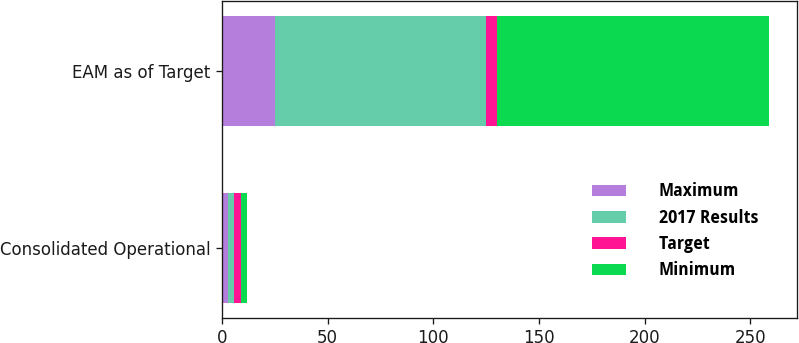Convert chart to OTSL. <chart><loc_0><loc_0><loc_500><loc_500><stacked_bar_chart><ecel><fcel>Consolidated Operational<fcel>EAM as of Target<nl><fcel>Maximum<fcel>2.6<fcel>25<nl><fcel>2017 Results<fcel>3<fcel>100<nl><fcel>Target<fcel>3.4<fcel>5.05<nl><fcel>Minimum<fcel>2.77<fcel>129<nl></chart> 